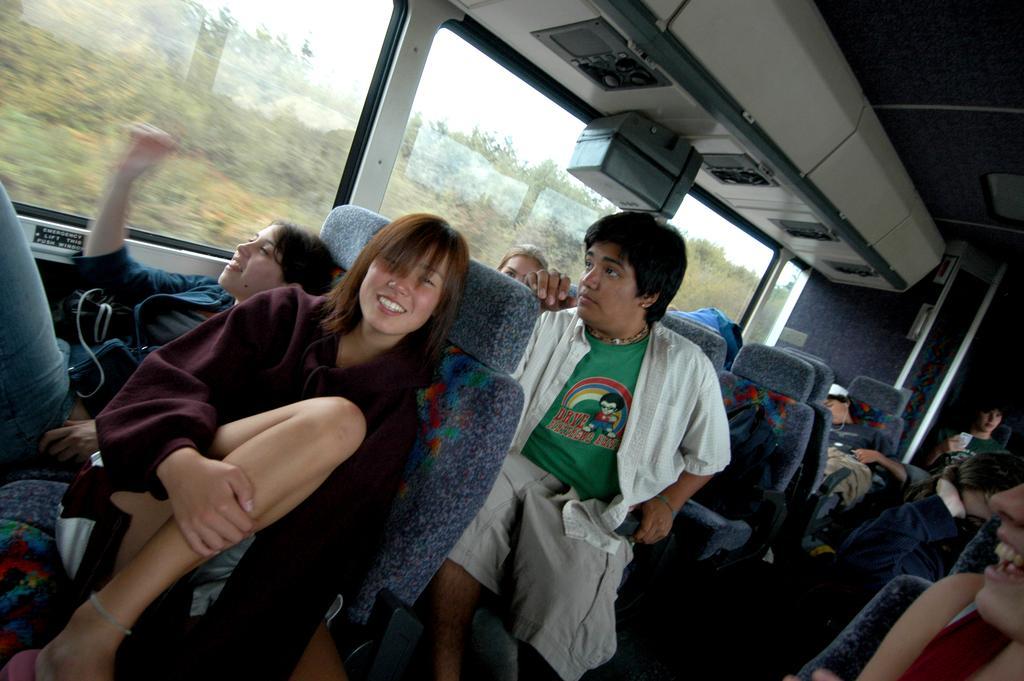Can you describe this image briefly? This image is taken inside a bus as we can see there are some persons sitting on the chairs, and there are widows at the top of this image. We can see there are some trees through this windows. 